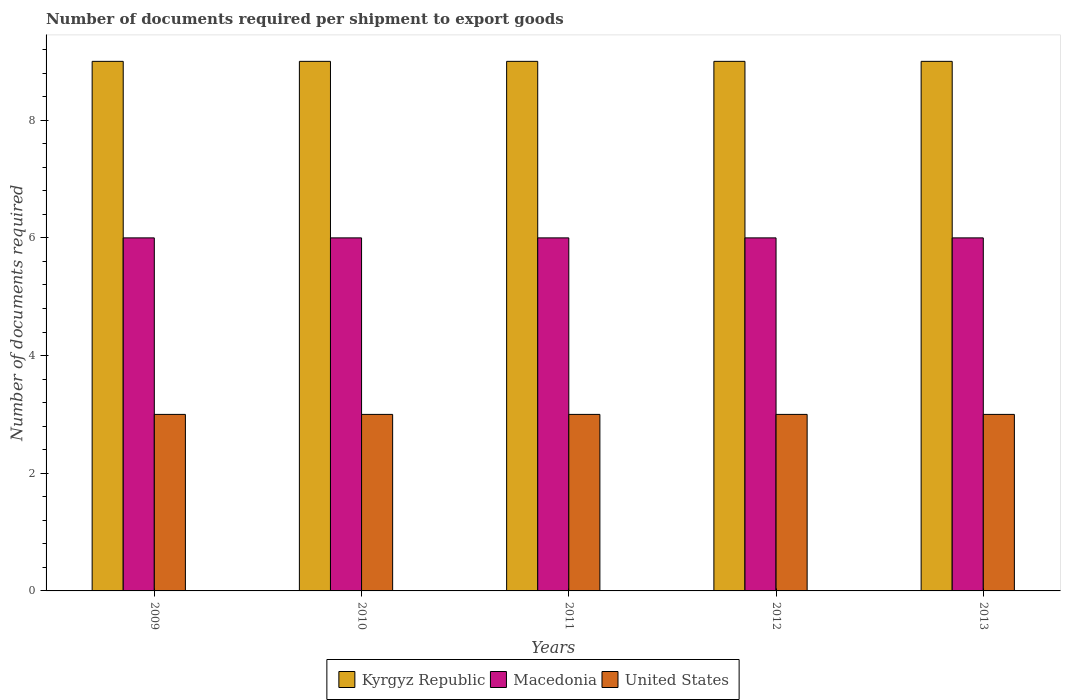How many groups of bars are there?
Ensure brevity in your answer.  5. Are the number of bars per tick equal to the number of legend labels?
Your answer should be compact. Yes. Are the number of bars on each tick of the X-axis equal?
Ensure brevity in your answer.  Yes. How many bars are there on the 2nd tick from the left?
Your answer should be compact. 3. How many bars are there on the 1st tick from the right?
Make the answer very short. 3. In how many cases, is the number of bars for a given year not equal to the number of legend labels?
Your answer should be compact. 0. What is the number of documents required per shipment to export goods in United States in 2012?
Provide a short and direct response. 3. Across all years, what is the maximum number of documents required per shipment to export goods in Kyrgyz Republic?
Offer a terse response. 9. Across all years, what is the minimum number of documents required per shipment to export goods in Kyrgyz Republic?
Your response must be concise. 9. In which year was the number of documents required per shipment to export goods in Macedonia minimum?
Your answer should be compact. 2009. What is the total number of documents required per shipment to export goods in Kyrgyz Republic in the graph?
Provide a succinct answer. 45. What is the difference between the number of documents required per shipment to export goods in Kyrgyz Republic in 2010 and the number of documents required per shipment to export goods in Macedonia in 2013?
Your response must be concise. 3. In the year 2010, what is the difference between the number of documents required per shipment to export goods in Macedonia and number of documents required per shipment to export goods in United States?
Your answer should be very brief. 3. In how many years, is the number of documents required per shipment to export goods in Kyrgyz Republic greater than 5.6?
Provide a short and direct response. 5. What is the ratio of the number of documents required per shipment to export goods in Kyrgyz Republic in 2010 to that in 2013?
Ensure brevity in your answer.  1. What is the difference between the highest and the second highest number of documents required per shipment to export goods in Kyrgyz Republic?
Your answer should be very brief. 0. What does the 1st bar from the left in 2013 represents?
Your answer should be very brief. Kyrgyz Republic. What does the 2nd bar from the right in 2013 represents?
Your answer should be very brief. Macedonia. How many bars are there?
Keep it short and to the point. 15. Are all the bars in the graph horizontal?
Give a very brief answer. No. How many years are there in the graph?
Your answer should be very brief. 5. Where does the legend appear in the graph?
Your answer should be compact. Bottom center. What is the title of the graph?
Ensure brevity in your answer.  Number of documents required per shipment to export goods. What is the label or title of the Y-axis?
Offer a terse response. Number of documents required. What is the Number of documents required in Kyrgyz Republic in 2010?
Your answer should be compact. 9. What is the Number of documents required of Macedonia in 2010?
Make the answer very short. 6. What is the Number of documents required in United States in 2010?
Your answer should be very brief. 3. What is the Number of documents required of Kyrgyz Republic in 2011?
Provide a short and direct response. 9. What is the Number of documents required of Macedonia in 2012?
Make the answer very short. 6. What is the Number of documents required in United States in 2012?
Offer a very short reply. 3. What is the Number of documents required in Kyrgyz Republic in 2013?
Offer a terse response. 9. What is the Number of documents required of Macedonia in 2013?
Your response must be concise. 6. What is the Number of documents required in United States in 2013?
Your response must be concise. 3. Across all years, what is the minimum Number of documents required in Kyrgyz Republic?
Ensure brevity in your answer.  9. Across all years, what is the minimum Number of documents required of United States?
Your answer should be compact. 3. What is the total Number of documents required of Kyrgyz Republic in the graph?
Ensure brevity in your answer.  45. What is the total Number of documents required of Macedonia in the graph?
Your answer should be compact. 30. What is the total Number of documents required of United States in the graph?
Make the answer very short. 15. What is the difference between the Number of documents required in Kyrgyz Republic in 2009 and that in 2010?
Ensure brevity in your answer.  0. What is the difference between the Number of documents required of Macedonia in 2009 and that in 2010?
Make the answer very short. 0. What is the difference between the Number of documents required of Kyrgyz Republic in 2009 and that in 2011?
Offer a terse response. 0. What is the difference between the Number of documents required of Kyrgyz Republic in 2009 and that in 2013?
Your answer should be very brief. 0. What is the difference between the Number of documents required in Kyrgyz Republic in 2010 and that in 2011?
Your answer should be compact. 0. What is the difference between the Number of documents required of United States in 2010 and that in 2011?
Give a very brief answer. 0. What is the difference between the Number of documents required of Kyrgyz Republic in 2010 and that in 2012?
Offer a very short reply. 0. What is the difference between the Number of documents required in United States in 2010 and that in 2012?
Your answer should be very brief. 0. What is the difference between the Number of documents required in Kyrgyz Republic in 2010 and that in 2013?
Provide a short and direct response. 0. What is the difference between the Number of documents required of Macedonia in 2010 and that in 2013?
Your answer should be compact. 0. What is the difference between the Number of documents required of Kyrgyz Republic in 2011 and that in 2012?
Give a very brief answer. 0. What is the difference between the Number of documents required of Kyrgyz Republic in 2011 and that in 2013?
Keep it short and to the point. 0. What is the difference between the Number of documents required in Macedonia in 2011 and that in 2013?
Offer a very short reply. 0. What is the difference between the Number of documents required of Kyrgyz Republic in 2012 and that in 2013?
Ensure brevity in your answer.  0. What is the difference between the Number of documents required in Macedonia in 2012 and that in 2013?
Keep it short and to the point. 0. What is the difference between the Number of documents required of Kyrgyz Republic in 2009 and the Number of documents required of Macedonia in 2010?
Keep it short and to the point. 3. What is the difference between the Number of documents required of Macedonia in 2009 and the Number of documents required of United States in 2010?
Offer a terse response. 3. What is the difference between the Number of documents required of Kyrgyz Republic in 2009 and the Number of documents required of Macedonia in 2011?
Offer a terse response. 3. What is the difference between the Number of documents required of Kyrgyz Republic in 2009 and the Number of documents required of United States in 2011?
Your answer should be very brief. 6. What is the difference between the Number of documents required of Macedonia in 2009 and the Number of documents required of United States in 2012?
Give a very brief answer. 3. What is the difference between the Number of documents required of Kyrgyz Republic in 2009 and the Number of documents required of United States in 2013?
Provide a succinct answer. 6. What is the difference between the Number of documents required in Kyrgyz Republic in 2010 and the Number of documents required in Macedonia in 2011?
Offer a very short reply. 3. What is the difference between the Number of documents required in Kyrgyz Republic in 2010 and the Number of documents required in United States in 2011?
Ensure brevity in your answer.  6. What is the difference between the Number of documents required of Kyrgyz Republic in 2010 and the Number of documents required of Macedonia in 2013?
Give a very brief answer. 3. What is the difference between the Number of documents required of Kyrgyz Republic in 2010 and the Number of documents required of United States in 2013?
Your response must be concise. 6. What is the difference between the Number of documents required of Macedonia in 2010 and the Number of documents required of United States in 2013?
Ensure brevity in your answer.  3. What is the difference between the Number of documents required of Kyrgyz Republic in 2011 and the Number of documents required of United States in 2012?
Offer a terse response. 6. What is the difference between the Number of documents required in Kyrgyz Republic in 2011 and the Number of documents required in Macedonia in 2013?
Your response must be concise. 3. What is the difference between the Number of documents required in Kyrgyz Republic in 2011 and the Number of documents required in United States in 2013?
Make the answer very short. 6. What is the difference between the Number of documents required in Macedonia in 2011 and the Number of documents required in United States in 2013?
Your response must be concise. 3. What is the difference between the Number of documents required of Macedonia in 2012 and the Number of documents required of United States in 2013?
Your answer should be compact. 3. What is the average Number of documents required of Kyrgyz Republic per year?
Offer a very short reply. 9. What is the average Number of documents required of Macedonia per year?
Your response must be concise. 6. In the year 2009, what is the difference between the Number of documents required in Kyrgyz Republic and Number of documents required in Macedonia?
Your answer should be compact. 3. In the year 2010, what is the difference between the Number of documents required of Kyrgyz Republic and Number of documents required of United States?
Make the answer very short. 6. In the year 2011, what is the difference between the Number of documents required in Kyrgyz Republic and Number of documents required in Macedonia?
Provide a succinct answer. 3. In the year 2011, what is the difference between the Number of documents required in Macedonia and Number of documents required in United States?
Your response must be concise. 3. In the year 2013, what is the difference between the Number of documents required in Kyrgyz Republic and Number of documents required in Macedonia?
Give a very brief answer. 3. In the year 2013, what is the difference between the Number of documents required in Macedonia and Number of documents required in United States?
Your response must be concise. 3. What is the ratio of the Number of documents required of Kyrgyz Republic in 2009 to that in 2010?
Provide a short and direct response. 1. What is the ratio of the Number of documents required of Macedonia in 2009 to that in 2010?
Provide a succinct answer. 1. What is the ratio of the Number of documents required of United States in 2009 to that in 2010?
Your response must be concise. 1. What is the ratio of the Number of documents required in Macedonia in 2009 to that in 2012?
Make the answer very short. 1. What is the ratio of the Number of documents required of Kyrgyz Republic in 2009 to that in 2013?
Provide a succinct answer. 1. What is the ratio of the Number of documents required in Kyrgyz Republic in 2010 to that in 2011?
Your response must be concise. 1. What is the ratio of the Number of documents required in Macedonia in 2010 to that in 2011?
Provide a succinct answer. 1. What is the ratio of the Number of documents required of Kyrgyz Republic in 2010 to that in 2012?
Your answer should be compact. 1. What is the ratio of the Number of documents required in Macedonia in 2010 to that in 2012?
Give a very brief answer. 1. What is the ratio of the Number of documents required in Kyrgyz Republic in 2010 to that in 2013?
Provide a succinct answer. 1. What is the ratio of the Number of documents required of Macedonia in 2010 to that in 2013?
Your response must be concise. 1. What is the ratio of the Number of documents required in United States in 2010 to that in 2013?
Keep it short and to the point. 1. What is the ratio of the Number of documents required in Kyrgyz Republic in 2011 to that in 2013?
Ensure brevity in your answer.  1. What is the ratio of the Number of documents required in Macedonia in 2011 to that in 2013?
Make the answer very short. 1. What is the ratio of the Number of documents required of Macedonia in 2012 to that in 2013?
Ensure brevity in your answer.  1. What is the difference between the highest and the second highest Number of documents required of Kyrgyz Republic?
Offer a very short reply. 0. What is the difference between the highest and the second highest Number of documents required in Macedonia?
Your answer should be very brief. 0. What is the difference between the highest and the second highest Number of documents required of United States?
Give a very brief answer. 0. What is the difference between the highest and the lowest Number of documents required of Kyrgyz Republic?
Make the answer very short. 0. What is the difference between the highest and the lowest Number of documents required of United States?
Provide a succinct answer. 0. 